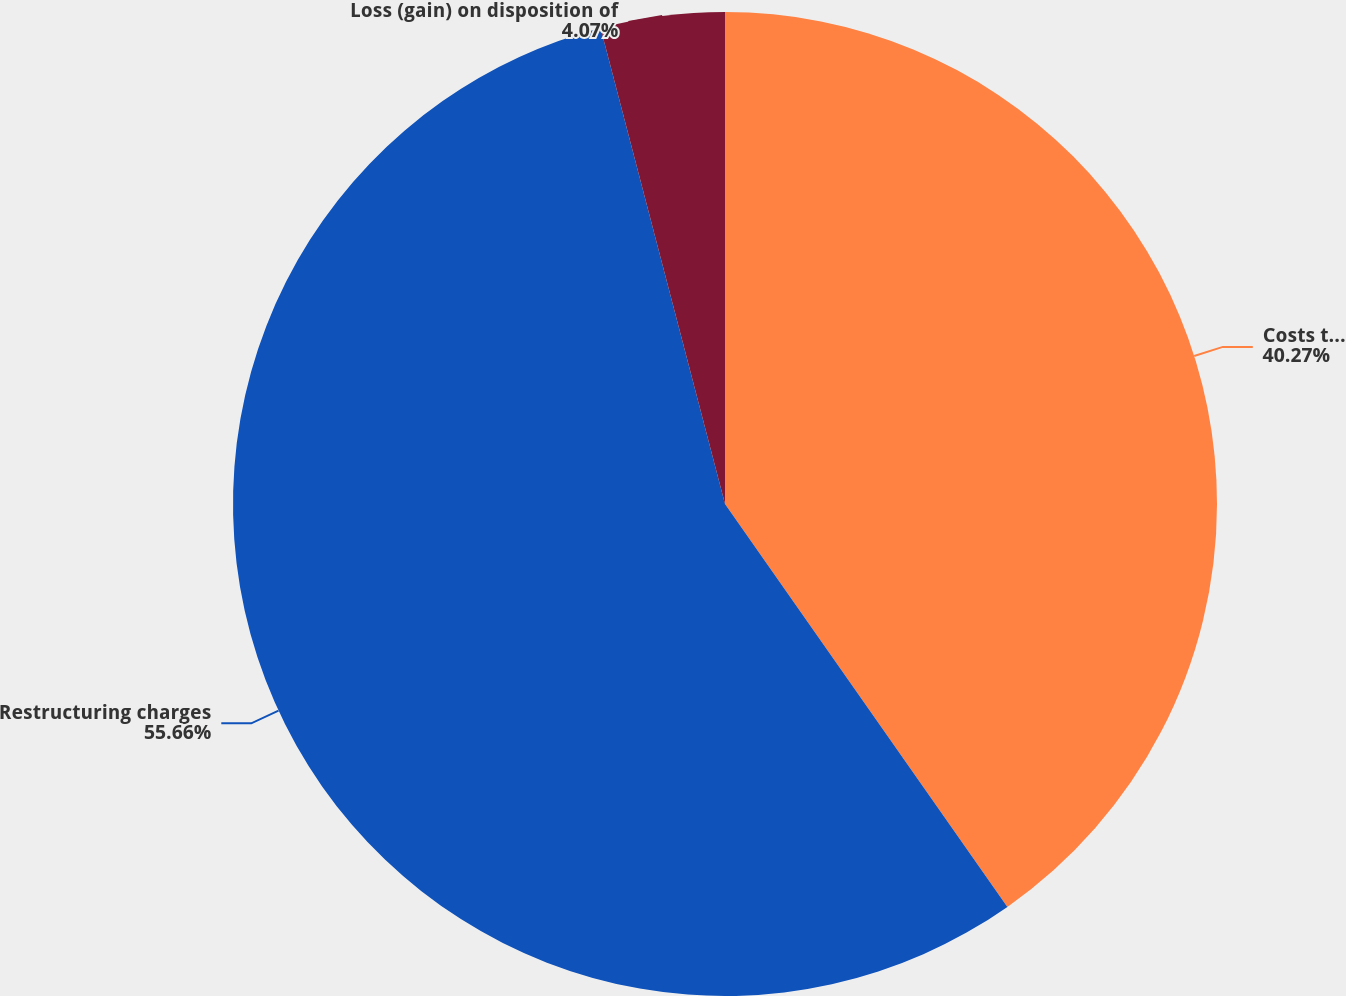Convert chart to OTSL. <chart><loc_0><loc_0><loc_500><loc_500><pie_chart><fcel>Costs to achieve synergies<fcel>Restructuring charges<fcel>Loss (gain) on disposition of<nl><fcel>40.27%<fcel>55.66%<fcel>4.07%<nl></chart> 